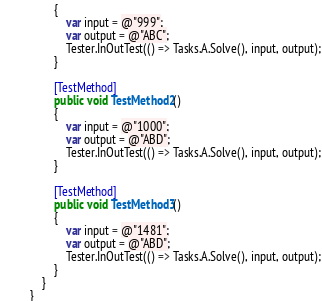<code> <loc_0><loc_0><loc_500><loc_500><_C#_>        {
            var input = @"999";
            var output = @"ABC";
            Tester.InOutTest(() => Tasks.A.Solve(), input, output);
        }

        [TestMethod]
        public void TestMethod2()
        {
            var input = @"1000";
            var output = @"ABD";
            Tester.InOutTest(() => Tasks.A.Solve(), input, output);
        }

        [TestMethod]
        public void TestMethod3()
        {
            var input = @"1481";
            var output = @"ABD";
            Tester.InOutTest(() => Tasks.A.Solve(), input, output);
        }
    }
}
</code> 